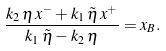Convert formula to latex. <formula><loc_0><loc_0><loc_500><loc_500>\frac { k _ { 2 } \, \eta \, x ^ { - } + k _ { 1 } \, \tilde { \eta } \, x ^ { + } } { k _ { 1 } \, \tilde { \eta } - k _ { 2 } \, \eta } = x _ { B } .</formula> 